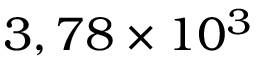<formula> <loc_0><loc_0><loc_500><loc_500>3 , 7 8 \times 1 0 ^ { 3 }</formula> 